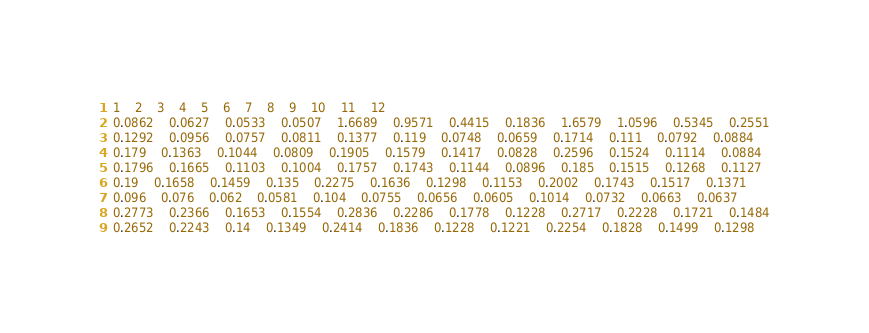<code> <loc_0><loc_0><loc_500><loc_500><_SQL_>1	2	3	4	5	6	7	8	9	10	11	12
0.0862	0.0627	0.0533	0.0507	1.6689	0.9571	0.4415	0.1836	1.6579	1.0596	0.5345	0.2551
0.1292	0.0956	0.0757	0.0811	0.1377	0.119	0.0748	0.0659	0.1714	0.111	0.0792	0.0884
0.179	0.1363	0.1044	0.0809	0.1905	0.1579	0.1417	0.0828	0.2596	0.1524	0.1114	0.0884
0.1796	0.1665	0.1103	0.1004	0.1757	0.1743	0.1144	0.0896	0.185	0.1515	0.1268	0.1127
0.19	0.1658	0.1459	0.135	0.2275	0.1636	0.1298	0.1153	0.2002	0.1743	0.1517	0.1371
0.096	0.076	0.062	0.0581	0.104	0.0755	0.0656	0.0605	0.1014	0.0732	0.0663	0.0637
0.2773	0.2366	0.1653	0.1554	0.2836	0.2286	0.1778	0.1228	0.2717	0.2228	0.1721	0.1484
0.2652	0.2243	0.14	0.1349	0.2414	0.1836	0.1228	0.1221	0.2254	0.1828	0.1499	0.1298
</code> 